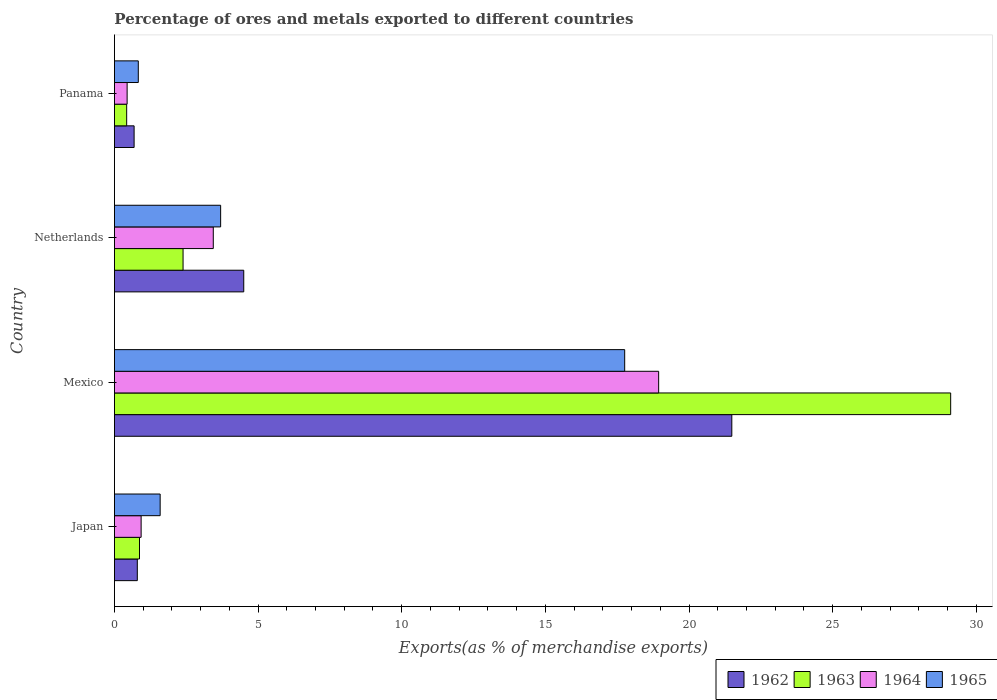How many groups of bars are there?
Keep it short and to the point. 4. Are the number of bars per tick equal to the number of legend labels?
Offer a terse response. Yes. Are the number of bars on each tick of the Y-axis equal?
Give a very brief answer. Yes. How many bars are there on the 4th tick from the top?
Give a very brief answer. 4. What is the percentage of exports to different countries in 1964 in Panama?
Provide a short and direct response. 0.44. Across all countries, what is the maximum percentage of exports to different countries in 1965?
Provide a succinct answer. 17.76. Across all countries, what is the minimum percentage of exports to different countries in 1965?
Ensure brevity in your answer.  0.83. In which country was the percentage of exports to different countries in 1964 maximum?
Provide a succinct answer. Mexico. In which country was the percentage of exports to different countries in 1964 minimum?
Provide a short and direct response. Panama. What is the total percentage of exports to different countries in 1963 in the graph?
Your answer should be very brief. 32.8. What is the difference between the percentage of exports to different countries in 1962 in Japan and that in Panama?
Your response must be concise. 0.11. What is the difference between the percentage of exports to different countries in 1964 in Mexico and the percentage of exports to different countries in 1963 in Panama?
Ensure brevity in your answer.  18.52. What is the average percentage of exports to different countries in 1962 per country?
Provide a short and direct response. 6.87. What is the difference between the percentage of exports to different countries in 1962 and percentage of exports to different countries in 1964 in Panama?
Make the answer very short. 0.24. What is the ratio of the percentage of exports to different countries in 1965 in Japan to that in Netherlands?
Provide a succinct answer. 0.43. What is the difference between the highest and the second highest percentage of exports to different countries in 1965?
Ensure brevity in your answer.  14.06. What is the difference between the highest and the lowest percentage of exports to different countries in 1962?
Your answer should be very brief. 20.81. In how many countries, is the percentage of exports to different countries in 1965 greater than the average percentage of exports to different countries in 1965 taken over all countries?
Your response must be concise. 1. Is it the case that in every country, the sum of the percentage of exports to different countries in 1965 and percentage of exports to different countries in 1964 is greater than the sum of percentage of exports to different countries in 1962 and percentage of exports to different countries in 1963?
Provide a short and direct response. No. What does the 2nd bar from the top in Panama represents?
Your response must be concise. 1964. What does the 1st bar from the bottom in Japan represents?
Your answer should be compact. 1962. Are all the bars in the graph horizontal?
Offer a terse response. Yes. What is the difference between two consecutive major ticks on the X-axis?
Give a very brief answer. 5. Are the values on the major ticks of X-axis written in scientific E-notation?
Your answer should be compact. No. Does the graph contain grids?
Provide a succinct answer. No. Where does the legend appear in the graph?
Your answer should be compact. Bottom right. How many legend labels are there?
Provide a short and direct response. 4. What is the title of the graph?
Give a very brief answer. Percentage of ores and metals exported to different countries. Does "1961" appear as one of the legend labels in the graph?
Ensure brevity in your answer.  No. What is the label or title of the X-axis?
Give a very brief answer. Exports(as % of merchandise exports). What is the Exports(as % of merchandise exports) in 1962 in Japan?
Ensure brevity in your answer.  0.8. What is the Exports(as % of merchandise exports) in 1963 in Japan?
Your answer should be very brief. 0.87. What is the Exports(as % of merchandise exports) in 1964 in Japan?
Offer a very short reply. 0.93. What is the Exports(as % of merchandise exports) of 1965 in Japan?
Your response must be concise. 1.59. What is the Exports(as % of merchandise exports) of 1962 in Mexico?
Offer a terse response. 21.49. What is the Exports(as % of merchandise exports) of 1963 in Mexico?
Provide a short and direct response. 29.11. What is the Exports(as % of merchandise exports) of 1964 in Mexico?
Offer a very short reply. 18.94. What is the Exports(as % of merchandise exports) in 1965 in Mexico?
Your answer should be very brief. 17.76. What is the Exports(as % of merchandise exports) in 1962 in Netherlands?
Your answer should be very brief. 4.5. What is the Exports(as % of merchandise exports) in 1963 in Netherlands?
Your answer should be very brief. 2.39. What is the Exports(as % of merchandise exports) of 1964 in Netherlands?
Make the answer very short. 3.44. What is the Exports(as % of merchandise exports) in 1965 in Netherlands?
Ensure brevity in your answer.  3.7. What is the Exports(as % of merchandise exports) of 1962 in Panama?
Provide a short and direct response. 0.69. What is the Exports(as % of merchandise exports) in 1963 in Panama?
Offer a terse response. 0.43. What is the Exports(as % of merchandise exports) in 1964 in Panama?
Ensure brevity in your answer.  0.44. What is the Exports(as % of merchandise exports) of 1965 in Panama?
Keep it short and to the point. 0.83. Across all countries, what is the maximum Exports(as % of merchandise exports) in 1962?
Give a very brief answer. 21.49. Across all countries, what is the maximum Exports(as % of merchandise exports) of 1963?
Give a very brief answer. 29.11. Across all countries, what is the maximum Exports(as % of merchandise exports) in 1964?
Provide a succinct answer. 18.94. Across all countries, what is the maximum Exports(as % of merchandise exports) in 1965?
Give a very brief answer. 17.76. Across all countries, what is the minimum Exports(as % of merchandise exports) in 1962?
Offer a terse response. 0.69. Across all countries, what is the minimum Exports(as % of merchandise exports) in 1963?
Give a very brief answer. 0.43. Across all countries, what is the minimum Exports(as % of merchandise exports) in 1964?
Keep it short and to the point. 0.44. Across all countries, what is the minimum Exports(as % of merchandise exports) in 1965?
Offer a very short reply. 0.83. What is the total Exports(as % of merchandise exports) in 1962 in the graph?
Provide a succinct answer. 27.47. What is the total Exports(as % of merchandise exports) of 1963 in the graph?
Your answer should be compact. 32.8. What is the total Exports(as % of merchandise exports) of 1964 in the graph?
Ensure brevity in your answer.  23.76. What is the total Exports(as % of merchandise exports) in 1965 in the graph?
Your answer should be compact. 23.88. What is the difference between the Exports(as % of merchandise exports) of 1962 in Japan and that in Mexico?
Provide a succinct answer. -20.69. What is the difference between the Exports(as % of merchandise exports) in 1963 in Japan and that in Mexico?
Ensure brevity in your answer.  -28.24. What is the difference between the Exports(as % of merchandise exports) of 1964 in Japan and that in Mexico?
Give a very brief answer. -18.01. What is the difference between the Exports(as % of merchandise exports) of 1965 in Japan and that in Mexico?
Your answer should be compact. -16.17. What is the difference between the Exports(as % of merchandise exports) in 1962 in Japan and that in Netherlands?
Your answer should be compact. -3.7. What is the difference between the Exports(as % of merchandise exports) of 1963 in Japan and that in Netherlands?
Your response must be concise. -1.52. What is the difference between the Exports(as % of merchandise exports) of 1964 in Japan and that in Netherlands?
Your answer should be compact. -2.51. What is the difference between the Exports(as % of merchandise exports) in 1965 in Japan and that in Netherlands?
Make the answer very short. -2.11. What is the difference between the Exports(as % of merchandise exports) of 1962 in Japan and that in Panama?
Ensure brevity in your answer.  0.11. What is the difference between the Exports(as % of merchandise exports) in 1963 in Japan and that in Panama?
Provide a short and direct response. 0.45. What is the difference between the Exports(as % of merchandise exports) in 1964 in Japan and that in Panama?
Your answer should be compact. 0.49. What is the difference between the Exports(as % of merchandise exports) of 1965 in Japan and that in Panama?
Give a very brief answer. 0.76. What is the difference between the Exports(as % of merchandise exports) of 1962 in Mexico and that in Netherlands?
Give a very brief answer. 16.99. What is the difference between the Exports(as % of merchandise exports) of 1963 in Mexico and that in Netherlands?
Give a very brief answer. 26.72. What is the difference between the Exports(as % of merchandise exports) of 1964 in Mexico and that in Netherlands?
Keep it short and to the point. 15.5. What is the difference between the Exports(as % of merchandise exports) of 1965 in Mexico and that in Netherlands?
Offer a very short reply. 14.06. What is the difference between the Exports(as % of merchandise exports) in 1962 in Mexico and that in Panama?
Your response must be concise. 20.81. What is the difference between the Exports(as % of merchandise exports) in 1963 in Mexico and that in Panama?
Provide a short and direct response. 28.68. What is the difference between the Exports(as % of merchandise exports) of 1964 in Mexico and that in Panama?
Give a very brief answer. 18.5. What is the difference between the Exports(as % of merchandise exports) in 1965 in Mexico and that in Panama?
Make the answer very short. 16.93. What is the difference between the Exports(as % of merchandise exports) in 1962 in Netherlands and that in Panama?
Your response must be concise. 3.82. What is the difference between the Exports(as % of merchandise exports) in 1963 in Netherlands and that in Panama?
Your answer should be compact. 1.96. What is the difference between the Exports(as % of merchandise exports) in 1964 in Netherlands and that in Panama?
Offer a terse response. 3. What is the difference between the Exports(as % of merchandise exports) in 1965 in Netherlands and that in Panama?
Give a very brief answer. 2.87. What is the difference between the Exports(as % of merchandise exports) of 1962 in Japan and the Exports(as % of merchandise exports) of 1963 in Mexico?
Ensure brevity in your answer.  -28.31. What is the difference between the Exports(as % of merchandise exports) in 1962 in Japan and the Exports(as % of merchandise exports) in 1964 in Mexico?
Offer a terse response. -18.15. What is the difference between the Exports(as % of merchandise exports) of 1962 in Japan and the Exports(as % of merchandise exports) of 1965 in Mexico?
Offer a terse response. -16.97. What is the difference between the Exports(as % of merchandise exports) of 1963 in Japan and the Exports(as % of merchandise exports) of 1964 in Mexico?
Give a very brief answer. -18.07. What is the difference between the Exports(as % of merchandise exports) of 1963 in Japan and the Exports(as % of merchandise exports) of 1965 in Mexico?
Make the answer very short. -16.89. What is the difference between the Exports(as % of merchandise exports) in 1964 in Japan and the Exports(as % of merchandise exports) in 1965 in Mexico?
Offer a terse response. -16.83. What is the difference between the Exports(as % of merchandise exports) in 1962 in Japan and the Exports(as % of merchandise exports) in 1963 in Netherlands?
Give a very brief answer. -1.59. What is the difference between the Exports(as % of merchandise exports) in 1962 in Japan and the Exports(as % of merchandise exports) in 1964 in Netherlands?
Keep it short and to the point. -2.64. What is the difference between the Exports(as % of merchandise exports) in 1962 in Japan and the Exports(as % of merchandise exports) in 1965 in Netherlands?
Your answer should be compact. -2.9. What is the difference between the Exports(as % of merchandise exports) of 1963 in Japan and the Exports(as % of merchandise exports) of 1964 in Netherlands?
Your response must be concise. -2.57. What is the difference between the Exports(as % of merchandise exports) in 1963 in Japan and the Exports(as % of merchandise exports) in 1965 in Netherlands?
Your answer should be compact. -2.82. What is the difference between the Exports(as % of merchandise exports) in 1964 in Japan and the Exports(as % of merchandise exports) in 1965 in Netherlands?
Provide a short and direct response. -2.77. What is the difference between the Exports(as % of merchandise exports) of 1962 in Japan and the Exports(as % of merchandise exports) of 1963 in Panama?
Give a very brief answer. 0.37. What is the difference between the Exports(as % of merchandise exports) of 1962 in Japan and the Exports(as % of merchandise exports) of 1964 in Panama?
Offer a very short reply. 0.35. What is the difference between the Exports(as % of merchandise exports) in 1962 in Japan and the Exports(as % of merchandise exports) in 1965 in Panama?
Ensure brevity in your answer.  -0.03. What is the difference between the Exports(as % of merchandise exports) of 1963 in Japan and the Exports(as % of merchandise exports) of 1964 in Panama?
Provide a succinct answer. 0.43. What is the difference between the Exports(as % of merchandise exports) in 1963 in Japan and the Exports(as % of merchandise exports) in 1965 in Panama?
Your answer should be compact. 0.04. What is the difference between the Exports(as % of merchandise exports) in 1964 in Japan and the Exports(as % of merchandise exports) in 1965 in Panama?
Make the answer very short. 0.1. What is the difference between the Exports(as % of merchandise exports) in 1962 in Mexico and the Exports(as % of merchandise exports) in 1963 in Netherlands?
Make the answer very short. 19.1. What is the difference between the Exports(as % of merchandise exports) in 1962 in Mexico and the Exports(as % of merchandise exports) in 1964 in Netherlands?
Your answer should be compact. 18.05. What is the difference between the Exports(as % of merchandise exports) of 1962 in Mexico and the Exports(as % of merchandise exports) of 1965 in Netherlands?
Your response must be concise. 17.79. What is the difference between the Exports(as % of merchandise exports) in 1963 in Mexico and the Exports(as % of merchandise exports) in 1964 in Netherlands?
Ensure brevity in your answer.  25.67. What is the difference between the Exports(as % of merchandise exports) of 1963 in Mexico and the Exports(as % of merchandise exports) of 1965 in Netherlands?
Your response must be concise. 25.41. What is the difference between the Exports(as % of merchandise exports) in 1964 in Mexico and the Exports(as % of merchandise exports) in 1965 in Netherlands?
Ensure brevity in your answer.  15.25. What is the difference between the Exports(as % of merchandise exports) of 1962 in Mexico and the Exports(as % of merchandise exports) of 1963 in Panama?
Keep it short and to the point. 21.06. What is the difference between the Exports(as % of merchandise exports) in 1962 in Mexico and the Exports(as % of merchandise exports) in 1964 in Panama?
Ensure brevity in your answer.  21.05. What is the difference between the Exports(as % of merchandise exports) of 1962 in Mexico and the Exports(as % of merchandise exports) of 1965 in Panama?
Provide a short and direct response. 20.66. What is the difference between the Exports(as % of merchandise exports) in 1963 in Mexico and the Exports(as % of merchandise exports) in 1964 in Panama?
Provide a succinct answer. 28.67. What is the difference between the Exports(as % of merchandise exports) in 1963 in Mexico and the Exports(as % of merchandise exports) in 1965 in Panama?
Your answer should be compact. 28.28. What is the difference between the Exports(as % of merchandise exports) in 1964 in Mexico and the Exports(as % of merchandise exports) in 1965 in Panama?
Your response must be concise. 18.11. What is the difference between the Exports(as % of merchandise exports) in 1962 in Netherlands and the Exports(as % of merchandise exports) in 1963 in Panama?
Your answer should be compact. 4.07. What is the difference between the Exports(as % of merchandise exports) of 1962 in Netherlands and the Exports(as % of merchandise exports) of 1964 in Panama?
Give a very brief answer. 4.06. What is the difference between the Exports(as % of merchandise exports) of 1962 in Netherlands and the Exports(as % of merchandise exports) of 1965 in Panama?
Your answer should be compact. 3.67. What is the difference between the Exports(as % of merchandise exports) in 1963 in Netherlands and the Exports(as % of merchandise exports) in 1964 in Panama?
Give a very brief answer. 1.95. What is the difference between the Exports(as % of merchandise exports) of 1963 in Netherlands and the Exports(as % of merchandise exports) of 1965 in Panama?
Offer a terse response. 1.56. What is the difference between the Exports(as % of merchandise exports) of 1964 in Netherlands and the Exports(as % of merchandise exports) of 1965 in Panama?
Ensure brevity in your answer.  2.61. What is the average Exports(as % of merchandise exports) of 1962 per country?
Your response must be concise. 6.87. What is the average Exports(as % of merchandise exports) of 1963 per country?
Provide a short and direct response. 8.2. What is the average Exports(as % of merchandise exports) in 1964 per country?
Your answer should be very brief. 5.94. What is the average Exports(as % of merchandise exports) of 1965 per country?
Make the answer very short. 5.97. What is the difference between the Exports(as % of merchandise exports) of 1962 and Exports(as % of merchandise exports) of 1963 in Japan?
Offer a terse response. -0.08. What is the difference between the Exports(as % of merchandise exports) in 1962 and Exports(as % of merchandise exports) in 1964 in Japan?
Your response must be concise. -0.13. What is the difference between the Exports(as % of merchandise exports) of 1962 and Exports(as % of merchandise exports) of 1965 in Japan?
Provide a succinct answer. -0.8. What is the difference between the Exports(as % of merchandise exports) of 1963 and Exports(as % of merchandise exports) of 1964 in Japan?
Your answer should be very brief. -0.06. What is the difference between the Exports(as % of merchandise exports) in 1963 and Exports(as % of merchandise exports) in 1965 in Japan?
Your answer should be compact. -0.72. What is the difference between the Exports(as % of merchandise exports) of 1964 and Exports(as % of merchandise exports) of 1965 in Japan?
Provide a succinct answer. -0.66. What is the difference between the Exports(as % of merchandise exports) in 1962 and Exports(as % of merchandise exports) in 1963 in Mexico?
Keep it short and to the point. -7.62. What is the difference between the Exports(as % of merchandise exports) in 1962 and Exports(as % of merchandise exports) in 1964 in Mexico?
Offer a very short reply. 2.55. What is the difference between the Exports(as % of merchandise exports) of 1962 and Exports(as % of merchandise exports) of 1965 in Mexico?
Keep it short and to the point. 3.73. What is the difference between the Exports(as % of merchandise exports) of 1963 and Exports(as % of merchandise exports) of 1964 in Mexico?
Provide a succinct answer. 10.16. What is the difference between the Exports(as % of merchandise exports) of 1963 and Exports(as % of merchandise exports) of 1965 in Mexico?
Provide a short and direct response. 11.35. What is the difference between the Exports(as % of merchandise exports) in 1964 and Exports(as % of merchandise exports) in 1965 in Mexico?
Your response must be concise. 1.18. What is the difference between the Exports(as % of merchandise exports) in 1962 and Exports(as % of merchandise exports) in 1963 in Netherlands?
Your answer should be very brief. 2.11. What is the difference between the Exports(as % of merchandise exports) of 1962 and Exports(as % of merchandise exports) of 1964 in Netherlands?
Keep it short and to the point. 1.06. What is the difference between the Exports(as % of merchandise exports) of 1962 and Exports(as % of merchandise exports) of 1965 in Netherlands?
Make the answer very short. 0.8. What is the difference between the Exports(as % of merchandise exports) in 1963 and Exports(as % of merchandise exports) in 1964 in Netherlands?
Offer a terse response. -1.05. What is the difference between the Exports(as % of merchandise exports) in 1963 and Exports(as % of merchandise exports) in 1965 in Netherlands?
Offer a very short reply. -1.31. What is the difference between the Exports(as % of merchandise exports) in 1964 and Exports(as % of merchandise exports) in 1965 in Netherlands?
Offer a terse response. -0.26. What is the difference between the Exports(as % of merchandise exports) in 1962 and Exports(as % of merchandise exports) in 1963 in Panama?
Ensure brevity in your answer.  0.26. What is the difference between the Exports(as % of merchandise exports) in 1962 and Exports(as % of merchandise exports) in 1964 in Panama?
Your response must be concise. 0.24. What is the difference between the Exports(as % of merchandise exports) of 1962 and Exports(as % of merchandise exports) of 1965 in Panama?
Your answer should be very brief. -0.15. What is the difference between the Exports(as % of merchandise exports) in 1963 and Exports(as % of merchandise exports) in 1964 in Panama?
Your answer should be compact. -0.02. What is the difference between the Exports(as % of merchandise exports) in 1963 and Exports(as % of merchandise exports) in 1965 in Panama?
Your response must be concise. -0.4. What is the difference between the Exports(as % of merchandise exports) of 1964 and Exports(as % of merchandise exports) of 1965 in Panama?
Provide a succinct answer. -0.39. What is the ratio of the Exports(as % of merchandise exports) in 1962 in Japan to that in Mexico?
Your answer should be compact. 0.04. What is the ratio of the Exports(as % of merchandise exports) of 1963 in Japan to that in Mexico?
Offer a terse response. 0.03. What is the ratio of the Exports(as % of merchandise exports) of 1964 in Japan to that in Mexico?
Ensure brevity in your answer.  0.05. What is the ratio of the Exports(as % of merchandise exports) in 1965 in Japan to that in Mexico?
Give a very brief answer. 0.09. What is the ratio of the Exports(as % of merchandise exports) in 1962 in Japan to that in Netherlands?
Provide a short and direct response. 0.18. What is the ratio of the Exports(as % of merchandise exports) in 1963 in Japan to that in Netherlands?
Offer a very short reply. 0.37. What is the ratio of the Exports(as % of merchandise exports) in 1964 in Japan to that in Netherlands?
Offer a terse response. 0.27. What is the ratio of the Exports(as % of merchandise exports) in 1965 in Japan to that in Netherlands?
Provide a short and direct response. 0.43. What is the ratio of the Exports(as % of merchandise exports) in 1962 in Japan to that in Panama?
Provide a succinct answer. 1.16. What is the ratio of the Exports(as % of merchandise exports) of 1963 in Japan to that in Panama?
Provide a short and direct response. 2.05. What is the ratio of the Exports(as % of merchandise exports) of 1964 in Japan to that in Panama?
Keep it short and to the point. 2.1. What is the ratio of the Exports(as % of merchandise exports) of 1965 in Japan to that in Panama?
Provide a short and direct response. 1.92. What is the ratio of the Exports(as % of merchandise exports) in 1962 in Mexico to that in Netherlands?
Your answer should be very brief. 4.77. What is the ratio of the Exports(as % of merchandise exports) of 1963 in Mexico to that in Netherlands?
Your answer should be very brief. 12.18. What is the ratio of the Exports(as % of merchandise exports) in 1964 in Mexico to that in Netherlands?
Your answer should be very brief. 5.51. What is the ratio of the Exports(as % of merchandise exports) in 1965 in Mexico to that in Netherlands?
Ensure brevity in your answer.  4.8. What is the ratio of the Exports(as % of merchandise exports) of 1962 in Mexico to that in Panama?
Ensure brevity in your answer.  31.37. What is the ratio of the Exports(as % of merchandise exports) in 1963 in Mexico to that in Panama?
Offer a very short reply. 68.27. What is the ratio of the Exports(as % of merchandise exports) in 1964 in Mexico to that in Panama?
Offer a terse response. 42.84. What is the ratio of the Exports(as % of merchandise exports) of 1965 in Mexico to that in Panama?
Give a very brief answer. 21.38. What is the ratio of the Exports(as % of merchandise exports) of 1962 in Netherlands to that in Panama?
Your answer should be very brief. 6.57. What is the ratio of the Exports(as % of merchandise exports) of 1963 in Netherlands to that in Panama?
Your response must be concise. 5.6. What is the ratio of the Exports(as % of merchandise exports) in 1964 in Netherlands to that in Panama?
Provide a short and direct response. 7.78. What is the ratio of the Exports(as % of merchandise exports) of 1965 in Netherlands to that in Panama?
Give a very brief answer. 4.45. What is the difference between the highest and the second highest Exports(as % of merchandise exports) of 1962?
Give a very brief answer. 16.99. What is the difference between the highest and the second highest Exports(as % of merchandise exports) in 1963?
Offer a very short reply. 26.72. What is the difference between the highest and the second highest Exports(as % of merchandise exports) in 1964?
Your answer should be compact. 15.5. What is the difference between the highest and the second highest Exports(as % of merchandise exports) of 1965?
Make the answer very short. 14.06. What is the difference between the highest and the lowest Exports(as % of merchandise exports) in 1962?
Keep it short and to the point. 20.81. What is the difference between the highest and the lowest Exports(as % of merchandise exports) in 1963?
Provide a short and direct response. 28.68. What is the difference between the highest and the lowest Exports(as % of merchandise exports) of 1964?
Offer a very short reply. 18.5. What is the difference between the highest and the lowest Exports(as % of merchandise exports) in 1965?
Ensure brevity in your answer.  16.93. 